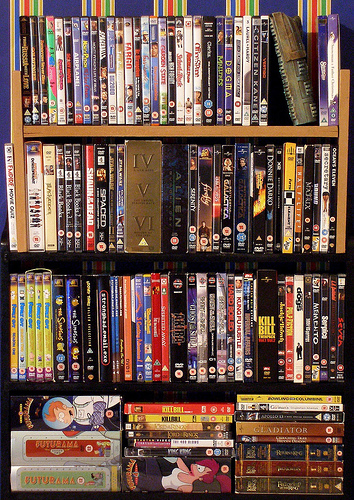<image>
Can you confirm if the book is on the shelf? No. The book is not positioned on the shelf. They may be near each other, but the book is not supported by or resting on top of the shelf. 